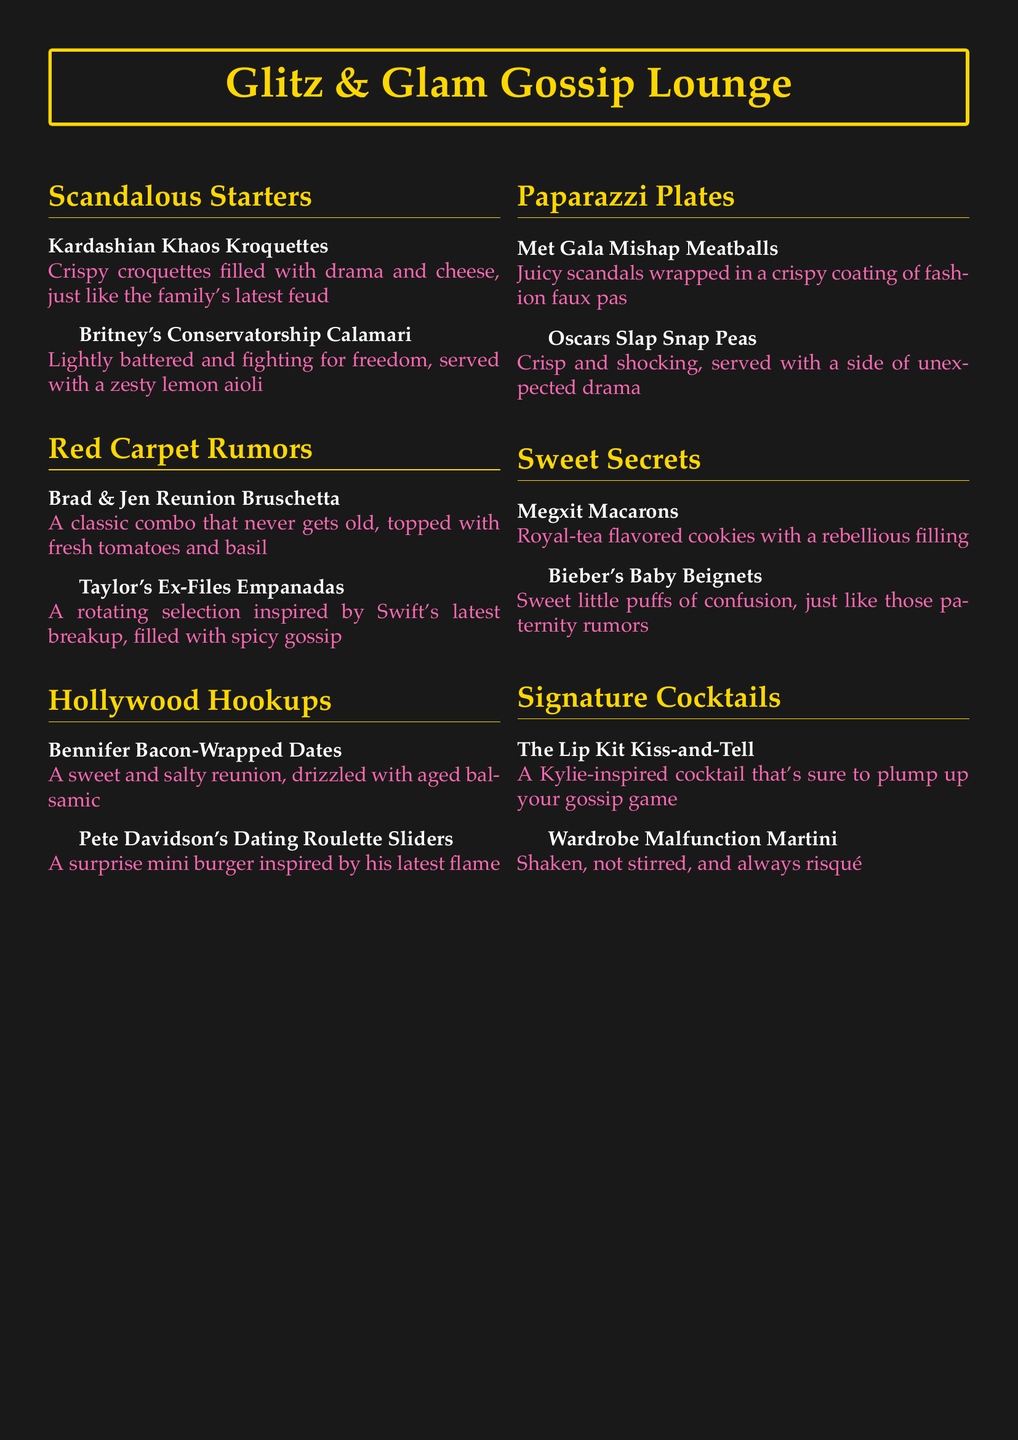what is the name of the tapas dish inspired by Britney Spears? The dish inspired by Britney Spears is called "Britney's Conservatorship Calamari."
Answer: Britney's Conservatorship Calamari how many sections are in the tapas menu? The menu has five sections: Scandalous Starters, Red Carpet Rumors, Hollywood Hookups, Paparazzi Plates, and Sweet Secrets.
Answer: Five sections what is served with the Oscars Slap Snap Peas? The Oscars Slap Snap Peas are served with a side of unexpected drama.
Answer: A side of unexpected drama which cocktail is inspired by Kylie Jenner? The cocktail inspired by Kylie Jenner is "The Lip Kit Kiss-and-Tell."
Answer: The Lip Kit Kiss-and-Tell what type of dish is the "Kardashian Khaos Kroquettes"? The "Kardashian Khaos Kroquettes" is a crispy croquette.
Answer: Crispy croquette what kind of filling do the "Megxit Macarons" have? The "Megxit Macarons" have a rebellious filling.
Answer: A rebellious filling how many items are listed under Sweet Secrets? There are two items listed under Sweet Secrets.
Answer: Two items what do the "Bennifer Bacon-Wrapped Dates" represent? The "Bennifer Bacon-Wrapped Dates" represent a sweet and salty reunion.
Answer: A sweet and salty reunion 